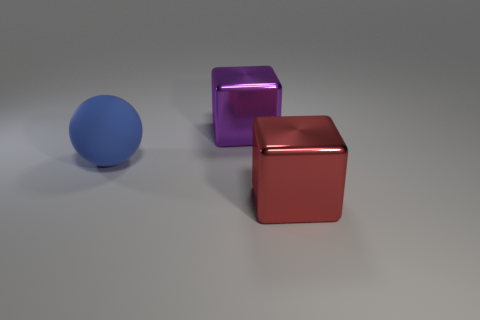Add 2 red shiny objects. How many objects exist? 5 Add 3 large red metallic things. How many large red metallic things exist? 4 Subtract all red cubes. How many cubes are left? 1 Subtract 0 purple cylinders. How many objects are left? 3 Subtract all balls. How many objects are left? 2 Subtract all green balls. Subtract all brown cylinders. How many balls are left? 1 Subtract all blue cylinders. How many green cubes are left? 0 Subtract all big purple shiny objects. Subtract all purple objects. How many objects are left? 1 Add 3 red things. How many red things are left? 4 